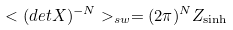<formula> <loc_0><loc_0><loc_500><loc_500>< ( d e t X ) ^ { - N } > _ { s w } = ( 2 \pi ) ^ { N } Z _ { \sinh }</formula> 